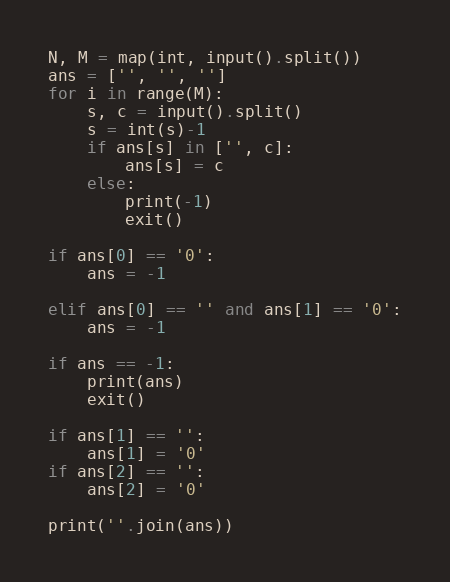<code> <loc_0><loc_0><loc_500><loc_500><_Python_>N, M = map(int, input().split()) 
ans = ['', '', '']
for i in range(M):
    s, c = input().split()
    s = int(s)-1
    if ans[s] in ['', c]:
        ans[s] = c
    else:
        print(-1)
        exit()

if ans[0] == '0':
    ans = -1
 
elif ans[0] == '' and ans[1] == '0':
    ans = -1

if ans == -1:
    print(ans)
    exit()

if ans[1] == '':
    ans[1] = '0'
if ans[2] == '':
    ans[2] = '0'

print(''.join(ans))</code> 